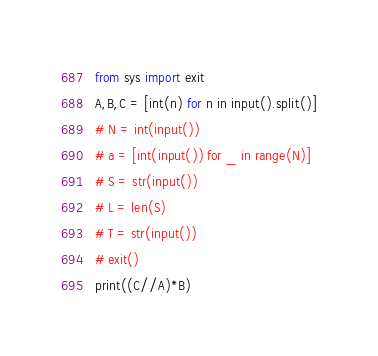Convert code to text. <code><loc_0><loc_0><loc_500><loc_500><_Python_>from sys import exit
A,B,C = [int(n) for n in input().split()]
# N = int(input())
# a = [int(input()) for _ in range(N)]
# S = str(input())
# L = len(S)
# T = str(input())
# exit()
print((C//A)*B)
</code> 